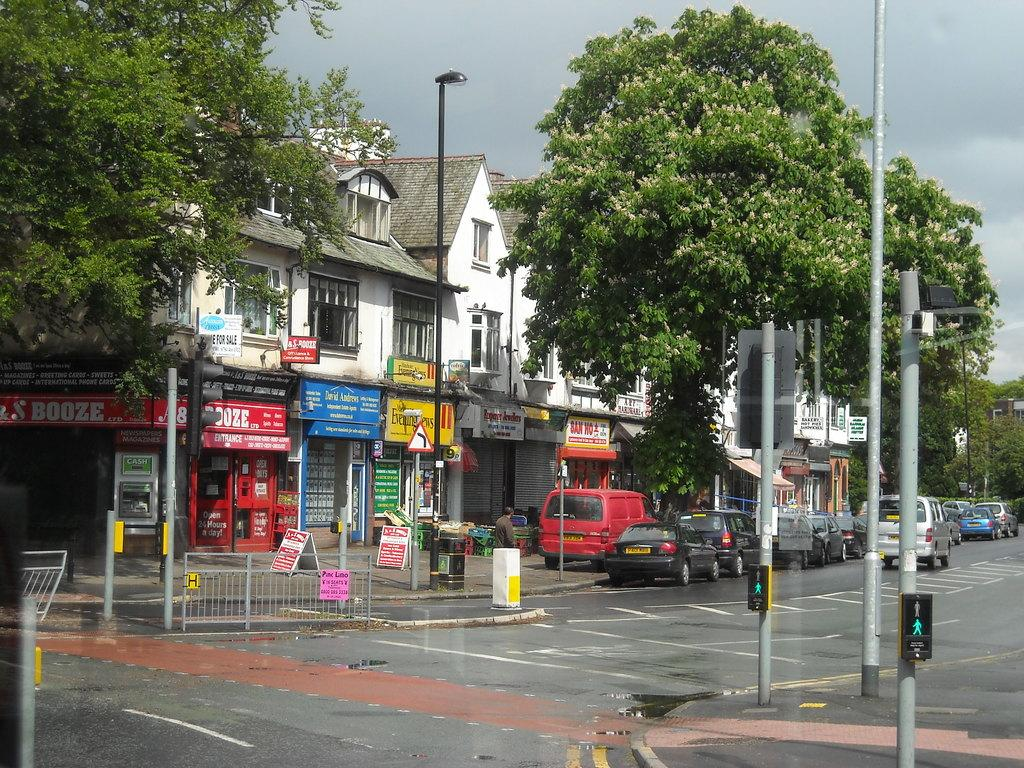<image>
Relay a brief, clear account of the picture shown. A corner market advertises on their awning that they sell booze. 